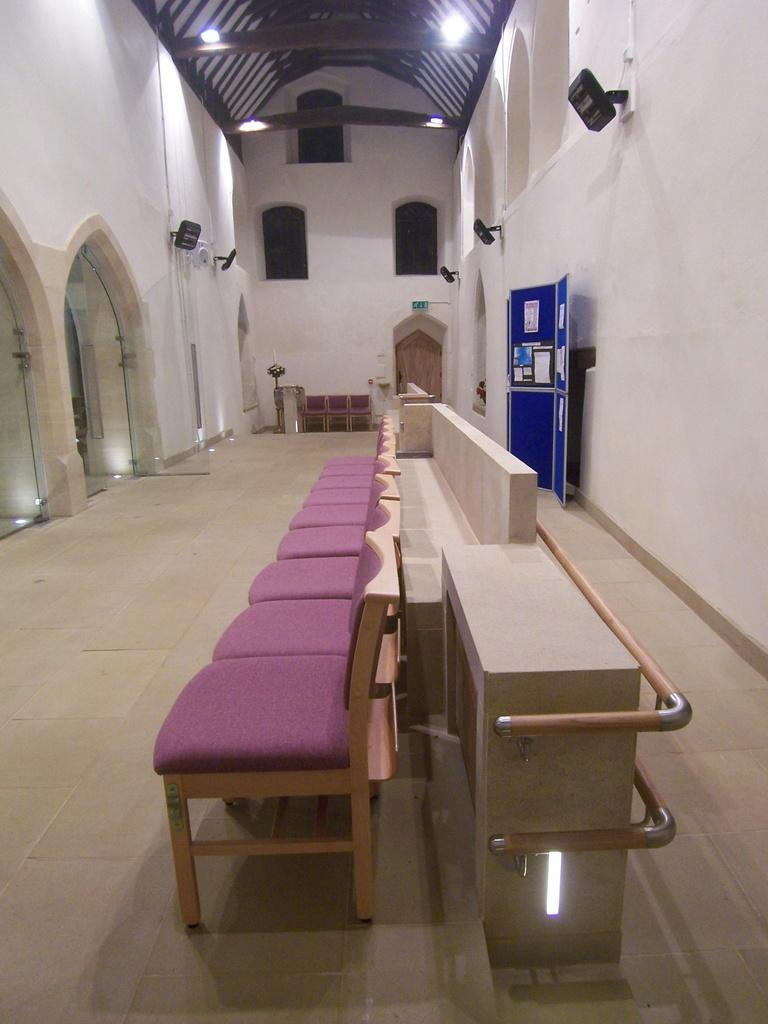What type of furniture is on the floor in the image? There are chairs on the floor in the image. What is attached to the boards in the image? There are posters on the boards in the image. What provides illumination in the image? There are lights in the image. What type of structure is visible in the image? There are walls and arches in the image. What objects can be seen in the image? There are some objects in the image. What architectural features are visible in the background of the image? There is a door, windows, and a roof visible in the background of the image. Can you see a square trail leading to the door in the image? There is no square trail visible in the image. Is there an airplane flying over the arches in the image? There is no airplane present in the image. 